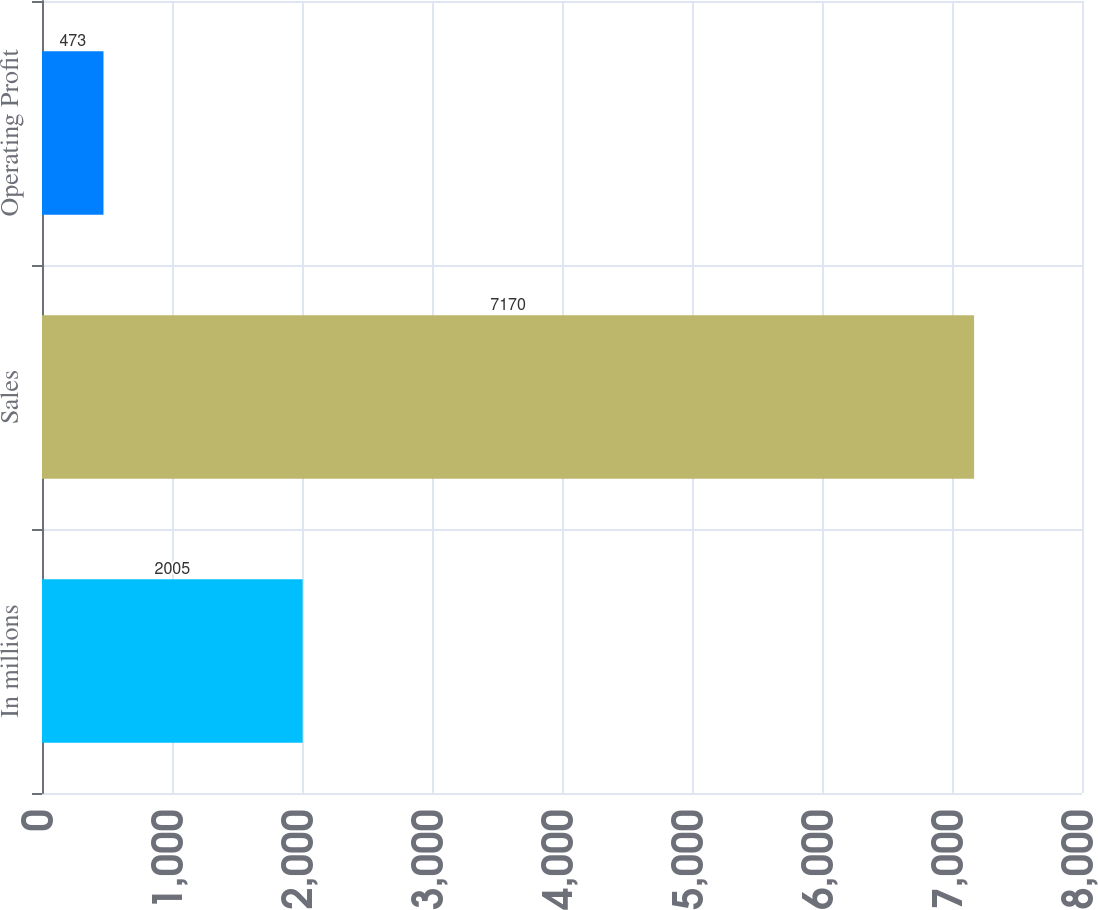Convert chart. <chart><loc_0><loc_0><loc_500><loc_500><bar_chart><fcel>In millions<fcel>Sales<fcel>Operating Profit<nl><fcel>2005<fcel>7170<fcel>473<nl></chart> 